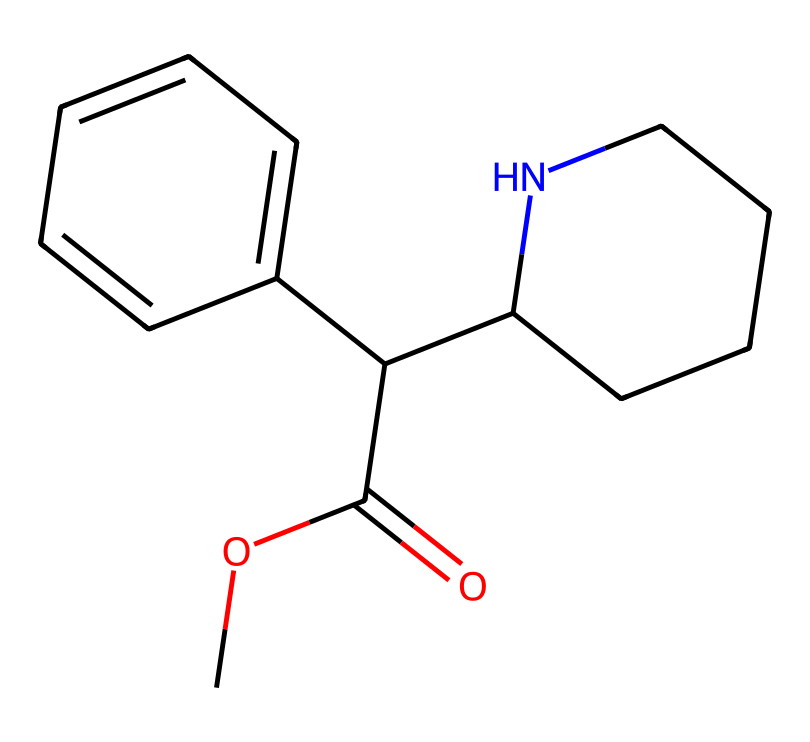What is the molecular formula of methylphenidate? To determine the molecular formula, count the number of carbon (C), hydrogen (H), oxygen (O), and nitrogen (N) atoms in the SMILES representation. There are 15 carbon atoms, 19 hydrogen atoms, 2 oxygen atoms, and 1 nitrogen atom, resulting in the molecular formula C15H19NO2.
Answer: C15H19NO2 How many rings are present in the structure of methylphenidate? By examining the structure in the SMILES, we note that there are two distinct cycles (rings), indicated by the numbers (C1 and C2 designated in the notation) which represent carbon atoms in the cycles.
Answer: 2 What type of functional group is present in methylphenidate? The presence of the C(=O)O indicates a carboxylic acid functional group (specifically an ester in this case), which is typical in medicinal compounds, affecting their solubility and reactivity.
Answer: ester What is the role of the nitrogen atom in methylphenidate? The nitrogen atom connects to a cyclic structure (piperidine), which contributes to the stimulant properties of the compound by interacting with neurotransmitters in the brain, thus playing a crucial role in its pharmacological activity.
Answer: stimulant Is methylphenidate a basic or an acidic compound? The presence of the aromatic ring and the nitrogen group suggests that methylphenidate has basic properties, as nitrogen in a piperidine structure can accept protons, indicating it is a basic compound.
Answer: basic How does the structure of methylphenidate relate to its function? Methylphenidate contains both a piperidine ring and an aromatic system, which are critical for binding to dopamine transporters in the brain, indicating its action is related to enhancing dopamine activity, crucial for treating ADHD.
Answer: enhances dopamine activity 